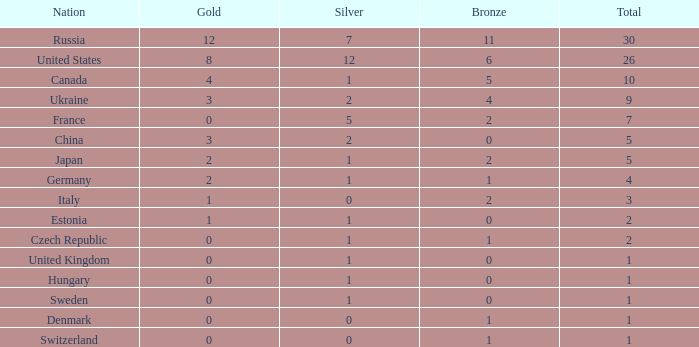Write the full table. {'header': ['Nation', 'Gold', 'Silver', 'Bronze', 'Total'], 'rows': [['Russia', '12', '7', '11', '30'], ['United States', '8', '12', '6', '26'], ['Canada', '4', '1', '5', '10'], ['Ukraine', '3', '2', '4', '9'], ['France', '0', '5', '2', '7'], ['China', '3', '2', '0', '5'], ['Japan', '2', '1', '2', '5'], ['Germany', '2', '1', '1', '4'], ['Italy', '1', '0', '2', '3'], ['Estonia', '1', '1', '0', '2'], ['Czech Republic', '0', '1', '1', '2'], ['United Kingdom', '0', '1', '0', '1'], ['Hungary', '0', '1', '0', '1'], ['Sweden', '0', '1', '0', '1'], ['Denmark', '0', '0', '1', '1'], ['Switzerland', '0', '0', '1', '1']]} What is the largest silver with Gold larger than 4, a Nation of united states, and a Total larger than 26? None. 